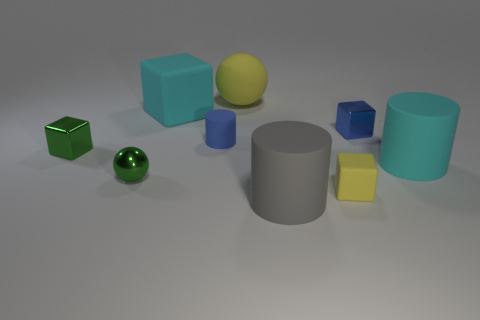Does the metal ball have the same color as the big sphere?
Make the answer very short. No. There is a metallic ball that is the same size as the blue shiny block; what is its color?
Your answer should be compact. Green. There is a sphere that is made of the same material as the cyan cube; what is its color?
Ensure brevity in your answer.  Yellow. There is a metal block that is right of the large yellow sphere; is its color the same as the small metallic sphere?
Your answer should be very brief. No. How many other metallic balls have the same color as the big sphere?
Keep it short and to the point. 0. The small object that is the same shape as the big yellow rubber thing is what color?
Give a very brief answer. Green. Do the cyan matte block and the gray rubber cylinder have the same size?
Provide a short and direct response. Yes. Are there an equal number of green metal balls that are in front of the small yellow rubber cube and large yellow balls that are on the left side of the shiny ball?
Offer a very short reply. Yes. Are there any yellow balls?
Your answer should be very brief. Yes. What size is the cyan thing that is the same shape as the gray matte object?
Provide a succinct answer. Large. 